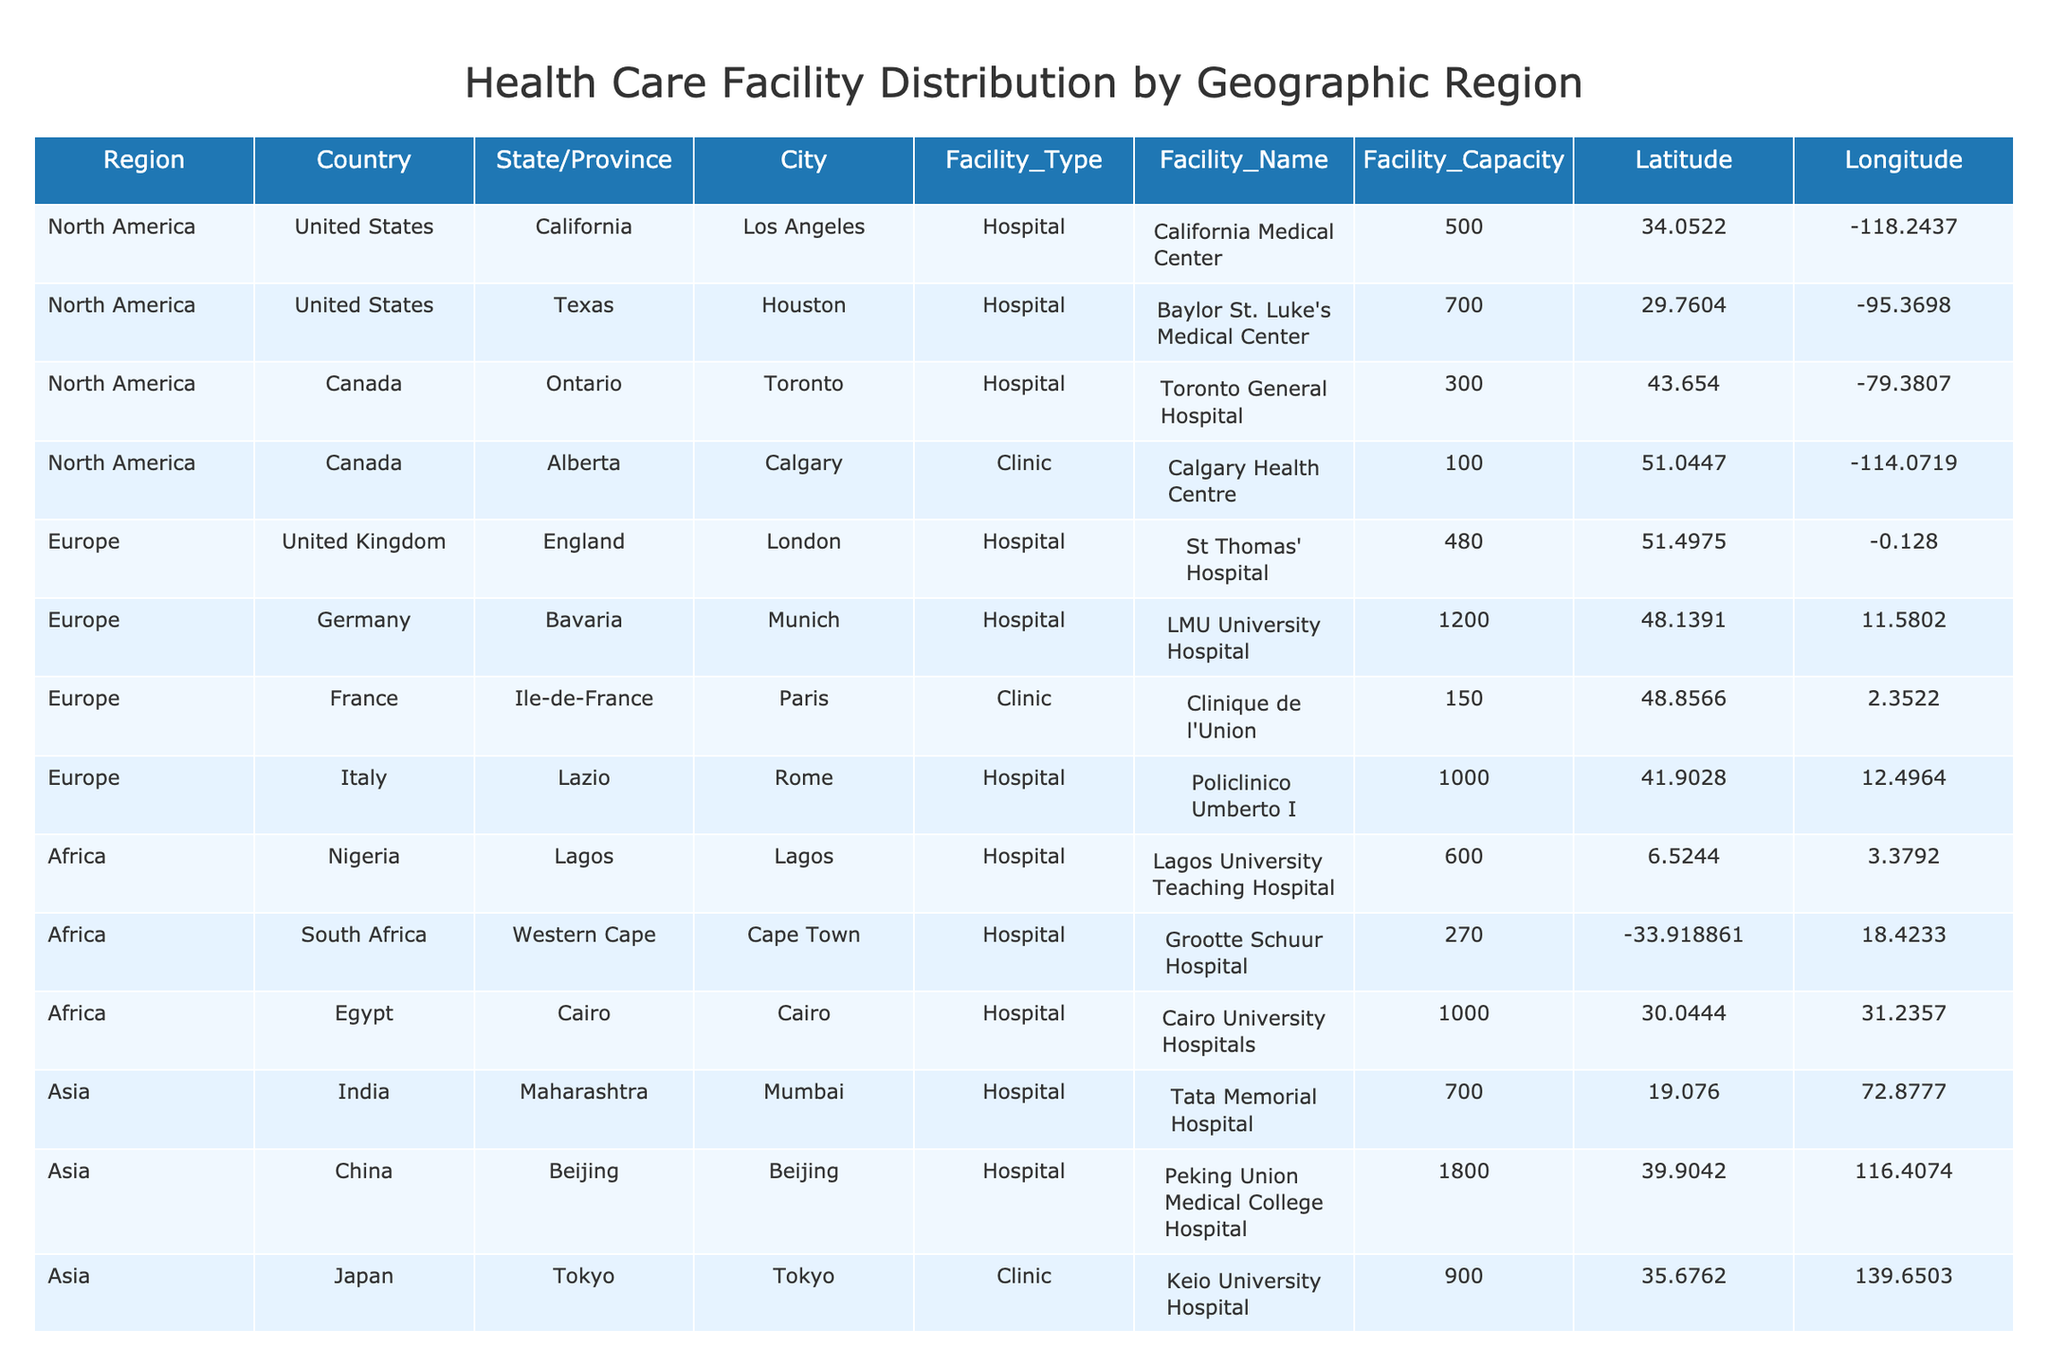What is the capacity of Baylor St. Luke's Medical Center? Baylor St. Luke's Medical Center is listed in the table under the Texas region with a facility capacity of 700.
Answer: 700 Which city has the highest capacity hospital? By comparing the facility capacities of all the hospitals in the table, Peking Union Medical College Hospital in Beijing has the highest capacity listed, which is 1800.
Answer: Beijing Is there a clinic located in Lagos, Nigeria? The table shows that facilities in Lagos include only Lagos University Teaching Hospital, which is a hospital, not a clinic.
Answer: No What is the total capacity of hospitals in North America? Hospitals in North America include California Medical Center (500), Baylor St. Luke's Medical Center (700), and Toronto General Hospital (300). Summing these capacities gives 500 + 700 + 300 = 1500.
Answer: 1500 Which country has more hospitals listed, Canada or India? Canada has two facilities listed: Toronto General Hospital (hospital) and Calgary Health Centre (clinic), while India has one facility listed: Tata Memorial Hospital (hospital). Since Canada has more overall facilities listed than India, the answer is Canada.
Answer: Canada What is the average capacity of the hospitals in Europe? The hospitals in Europe are St Thomas' Hospital (480), LMU University Hospital (1200), Policlinico Umberto I (1000). The total capacity is 480 + 1200 + 1000 = 2680, and there are three hospitals, so the average is 2680 divided by 3, which equals approximately 893.33.
Answer: 893.33 Do any facilities listed exceed a capacity of 1500? Checking the capacity of each facility, both Royal Prince Alfred Hospital in Sydney and Auckland City Hospital in Auckland exceed a capacity of 1500, confirming that there are indeed facilities that exceed this capacity.
Answer: Yes How many hospitals are located in South America? According to the table, there are two hospitals listed in South America: Hospital das Clínicas in São Paulo and Hospital Italiano in Buenos Aires.
Answer: 2 